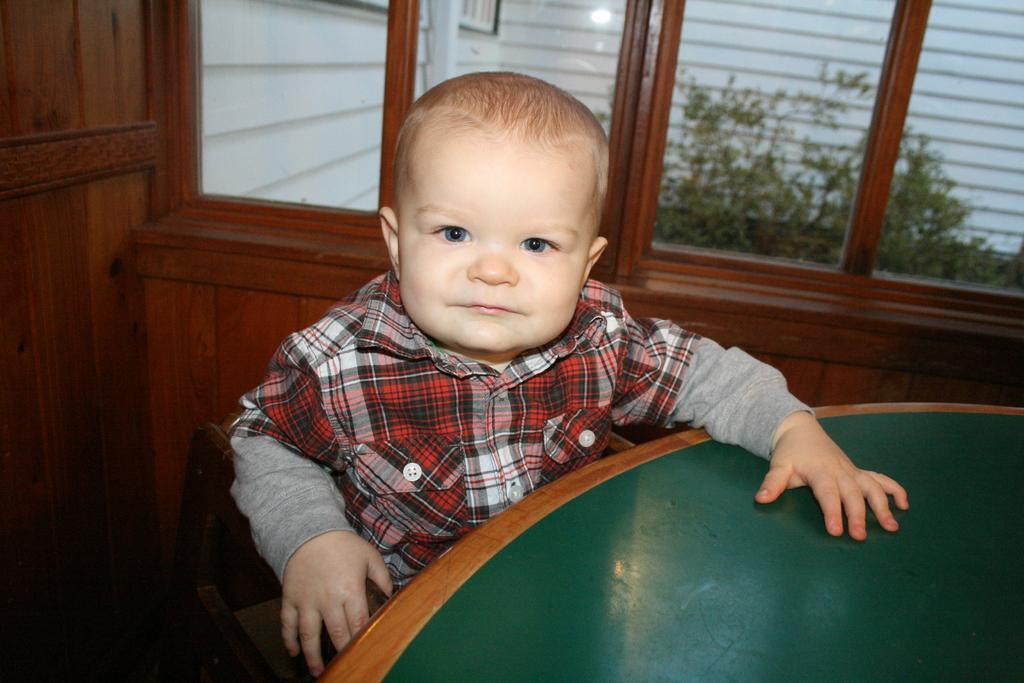In one or two sentences, can you explain what this image depicts? In this image we can see a boy is sitting on the chair. In front of the boy, we can see a table. In the background, we can see the windows. Behind the window, we can see planets and a wall. There is a wooden wall on the left side of the image. 